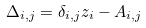<formula> <loc_0><loc_0><loc_500><loc_500>\Delta _ { i , j } = \delta _ { i , j } z _ { i } - A _ { i , j }</formula> 